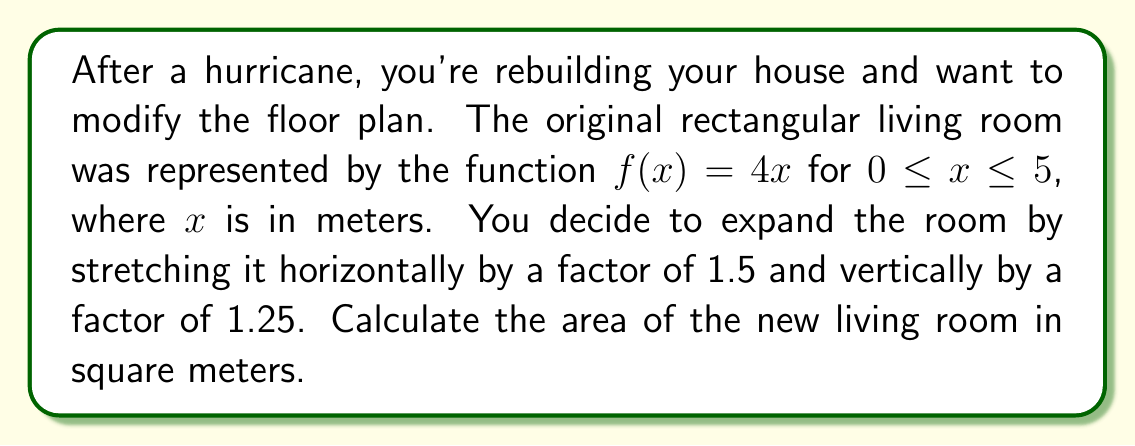Show me your answer to this math problem. Let's approach this step-by-step:

1) The original function is $f(x) = 4x$ for $0 \leq x \leq 5$.

2) The horizontal stretch by a factor of 1.5 is represented by $g(x) = f(\frac{x}{1.5})$:
   $g(x) = 4(\frac{x}{1.5}) = \frac{8x}{3}$

3) The vertical stretch by a factor of 1.25 is then applied:
   $h(x) = 1.25g(x) = 1.25(\frac{8x}{3}) = \frac{10x}{3}$

4) The new function is $h(x) = \frac{10x}{3}$

5) The original domain was $0 \leq x \leq 5$. After the horizontal stretch, the new domain is $0 \leq x \leq 7.5$ (because $5 * 1.5 = 7.5$).

6) To find the area, we need to integrate the new function over the new domain:

   $$A = \int_0^{7.5} \frac{10x}{3} dx$$

7) Solving the integral:
   $$A = \frac{10}{3} [\frac{x^2}{2}]_0^{7.5} = \frac{10}{3} (\frac{7.5^2}{2} - 0) = \frac{10}{3} * \frac{56.25}{2} = 93.75$$

Therefore, the area of the new living room is 93.75 square meters.
Answer: 93.75 square meters 